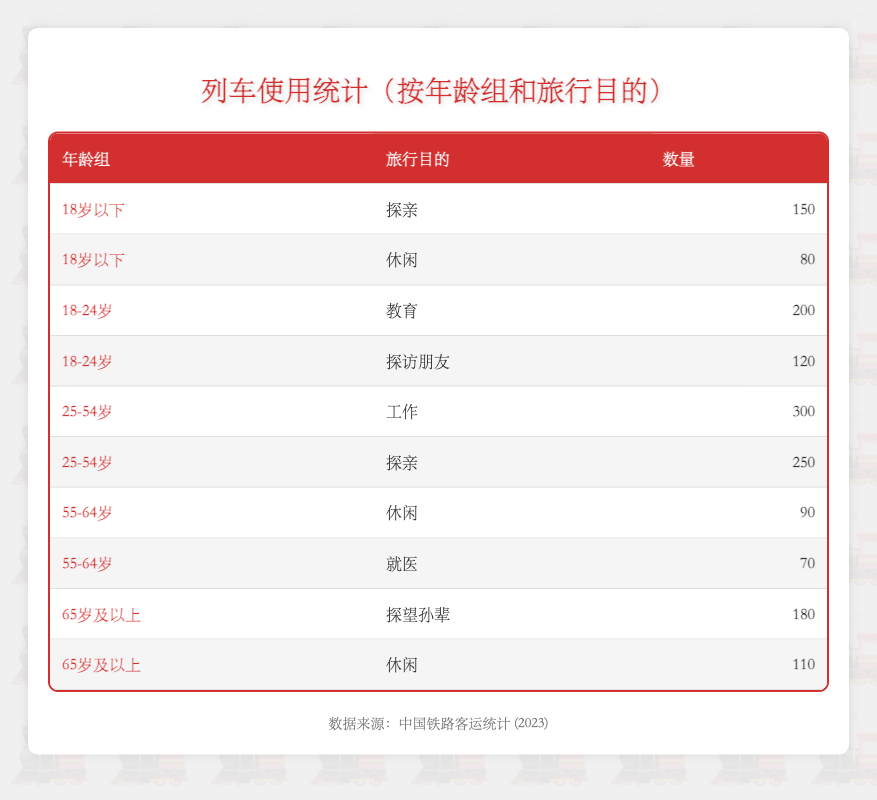What age group has the highest count for "Visiting Family"? In the table, the count for "Visiting Family" in the "Under 18" age group is 150, while in the "25-54" age group, it is 250. This is higher than any other age group. The other age groups do not exceed this count for the same purpose.
Answer: 25-54 What is the total count of train usage for "Leisure" across all age groups? To find the total count of train usage for "Leisure," we sum the counts for each relevant age group: Under 18 (80) + 55-64 (90) + 65 and older (110) = 280.
Answer: 280 Are there more people traveling for "Work" than for "Health Care"? The count for "Work" in the age group 25-54 is 300, while the count for "Health Care" for the 55-64 age group is 70. Since 300 is greater than 70, this statement is true.
Answer: Yes What is the difference between the counts for "Visiting Grandchildren" and "Visiting Family" for the 65 and older age group? The count for "Visiting Grandchildren" for the 65 and older age group is 180, and the count for "Visiting Family" is not applicable for this group (as there is no record). Therefore, it is only relevant to compare "Visiting Grandchildren" to other age groups for "Visiting Family." This means no direct difference can be calculated for "Visiting Family."
Answer: N/A Which age group and purpose has the least usage? From the table, the least count is seen in the "Health Care" category for the 55-64 age group with a count of 70. This is the lowest number among all age group purposes shown in the table.
Answer: 55-64 for Health Care What is the average count of train usage for the age group 18-24? The "18-24" age group has 2 travel purposes listed: Education (200) and Visiting Friends (120). The sum of these counts is 320. Dividing this sum by the number of purposes (2) gives an average of 320/2 = 160.
Answer: 160 How many more people travel for "Education" compared to "Leisure" in the 18-24 age group? For the "18-24" age group, the count for "Education" is 200, while "Leisure" does not apply. Since we cannot compare "Education" directly to "Leisure" within the same age group, this question results in unnecessary computation in comparison. However, comparing another row can be done if needed.
Answer: N/A Is it true that more people travel for "Visiting Friends" than for "Leisure" in the "Under 18" group? The count for "Visiting Friends" does not exist for the "Under 18" group, but "Leisure" has a count of 80. Thus, there are no users traveling for "Visiting Friends" in this particular age group.
Answer: No What percentage of the total train usage is made up by those traveling for "Visiting Family"? The total counts for "Visiting Family" are 150 (Under 18) + 250 (25-54) = 400. The overall total count for all purposes is 150 + 80 + 200 + 120 + 300 + 250 + 90 + 70 + 180 + 110 = 1550. Therefore, the percentage is (400/1550) * 100 = 25.81%.
Answer: 25.81% 